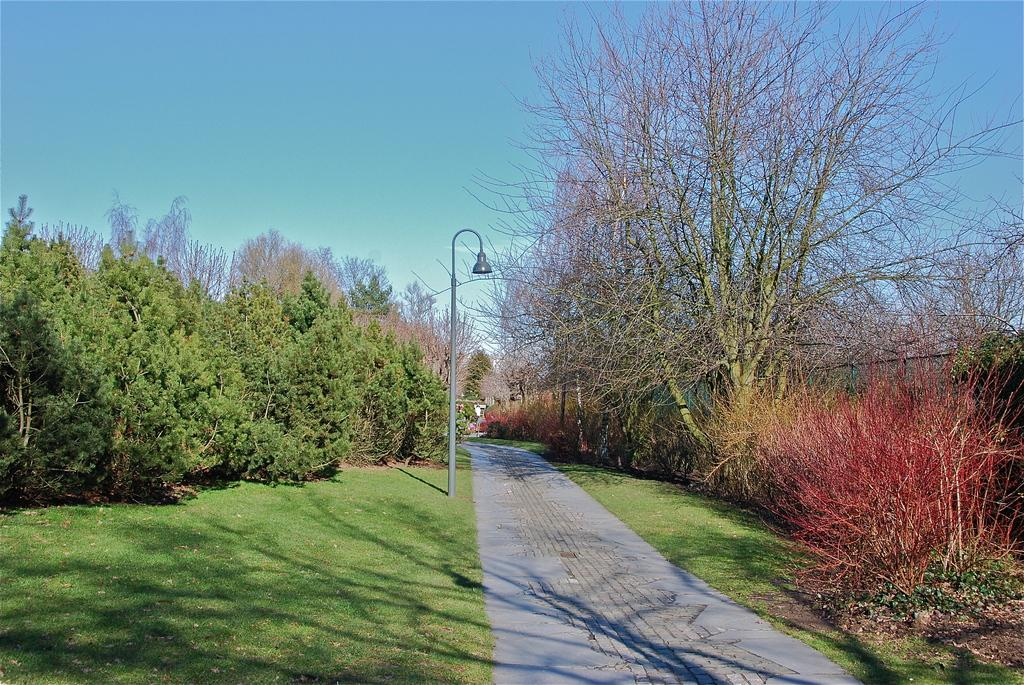What type of vegetation can be seen in the image? There are trees, bushes, and grass in the image. What else can be seen in the image besides vegetation? There appears to be a pathway and a street light in the image. What is the purpose of the muscle in the image? There is no muscle present in the image. Are there any cattle visible in the image? There are no cattle present in the image. 